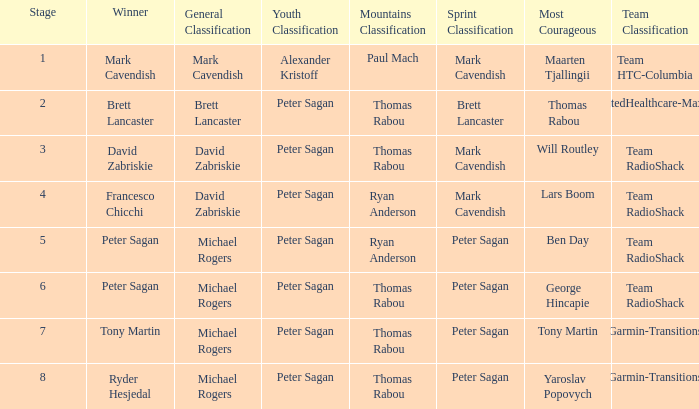Parse the full table. {'header': ['Stage', 'Winner', 'General Classification', 'Youth Classification', 'Mountains Classification', 'Sprint Classification', 'Most Courageous', 'Team Classification'], 'rows': [['1', 'Mark Cavendish', 'Mark Cavendish', 'Alexander Kristoff', 'Paul Mach', 'Mark Cavendish', 'Maarten Tjallingii', 'Team HTC-Columbia'], ['2', 'Brett Lancaster', 'Brett Lancaster', 'Peter Sagan', 'Thomas Rabou', 'Brett Lancaster', 'Thomas Rabou', 'UnitedHealthcare-Maxxis'], ['3', 'David Zabriskie', 'David Zabriskie', 'Peter Sagan', 'Thomas Rabou', 'Mark Cavendish', 'Will Routley', 'Team RadioShack'], ['4', 'Francesco Chicchi', 'David Zabriskie', 'Peter Sagan', 'Ryan Anderson', 'Mark Cavendish', 'Lars Boom', 'Team RadioShack'], ['5', 'Peter Sagan', 'Michael Rogers', 'Peter Sagan', 'Ryan Anderson', 'Peter Sagan', 'Ben Day', 'Team RadioShack'], ['6', 'Peter Sagan', 'Michael Rogers', 'Peter Sagan', 'Thomas Rabou', 'Peter Sagan', 'George Hincapie', 'Team RadioShack'], ['7', 'Tony Martin', 'Michael Rogers', 'Peter Sagan', 'Thomas Rabou', 'Peter Sagan', 'Tony Martin', 'Garmin-Transitions'], ['8', 'Ryder Hesjedal', 'Michael Rogers', 'Peter Sagan', 'Thomas Rabou', 'Peter Sagan', 'Yaroslav Popovych', 'Garmin-Transitions']]} When Yaroslav Popovych won most corageous, who won the mountains classification? Thomas Rabou. 